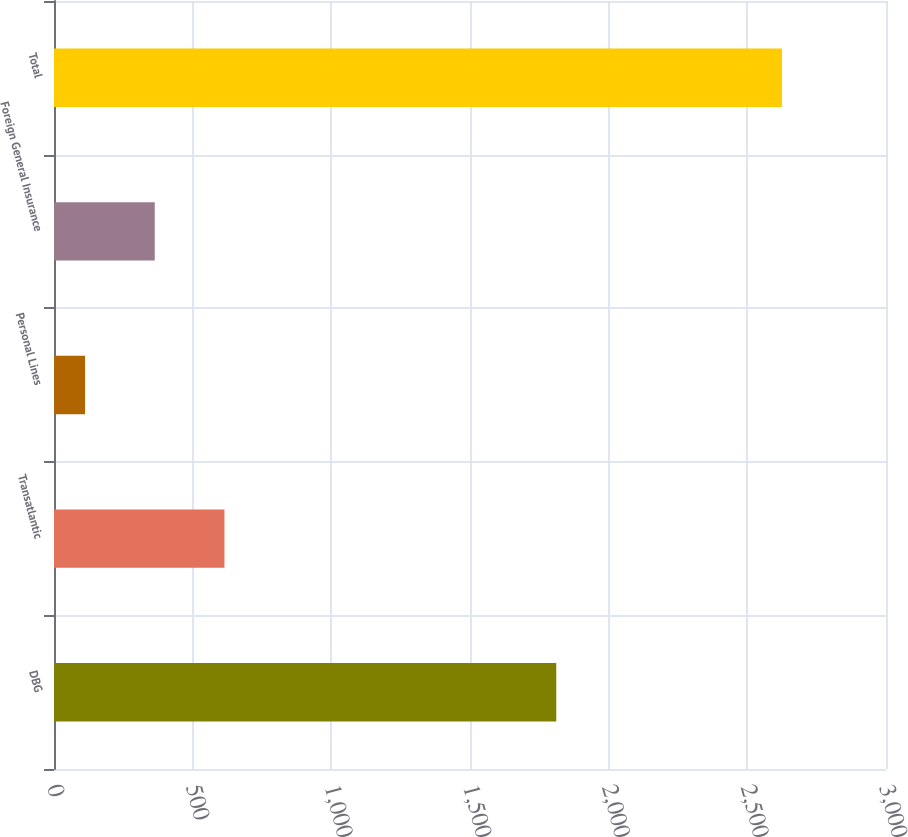Convert chart. <chart><loc_0><loc_0><loc_500><loc_500><bar_chart><fcel>DBG<fcel>Transatlantic<fcel>Personal Lines<fcel>Foreign General Insurance<fcel>Total<nl><fcel>1811<fcel>614.6<fcel>112<fcel>363.3<fcel>2625<nl></chart> 